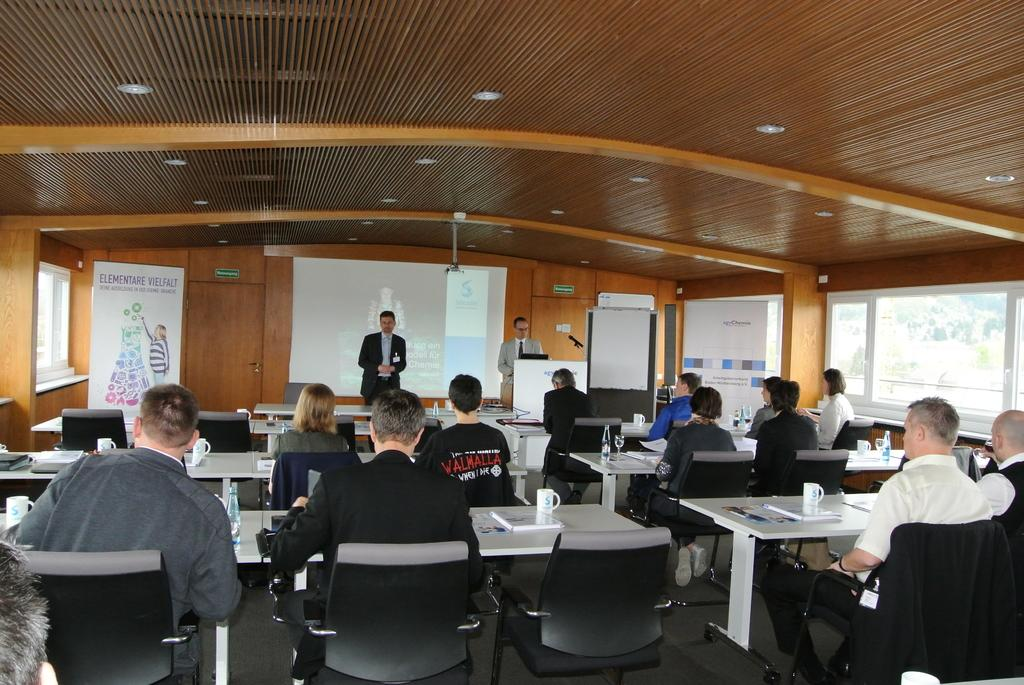How many people are in the image? There are multiple people in the image. What are the positions of the people in the image? Two of the people are standing, and the rest of the people are sitting. What can be seen in the background of the image? There is a white screen in the background of the image. What type of treatment is the grandfather receiving in the image? There is no grandfather or treatment present in the image. 